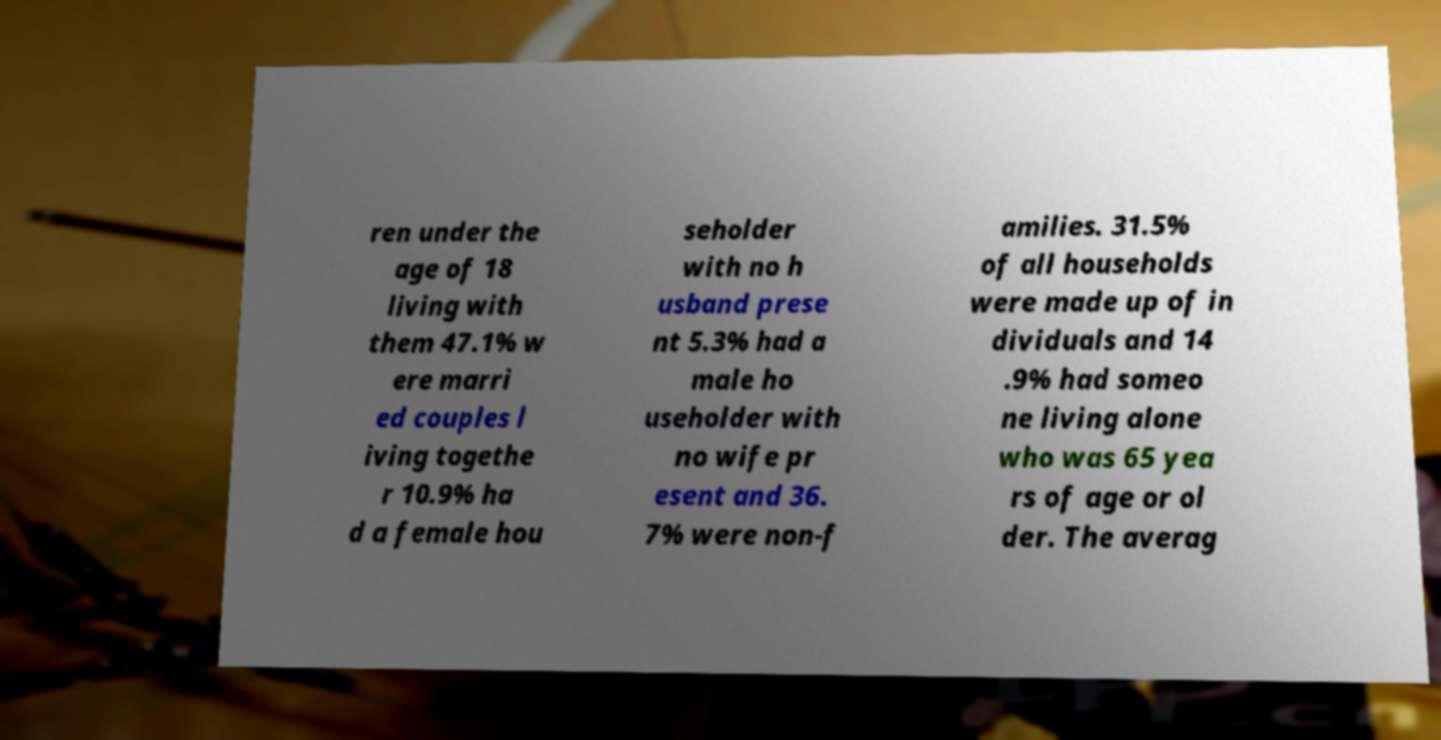Can you accurately transcribe the text from the provided image for me? ren under the age of 18 living with them 47.1% w ere marri ed couples l iving togethe r 10.9% ha d a female hou seholder with no h usband prese nt 5.3% had a male ho useholder with no wife pr esent and 36. 7% were non-f amilies. 31.5% of all households were made up of in dividuals and 14 .9% had someo ne living alone who was 65 yea rs of age or ol der. The averag 